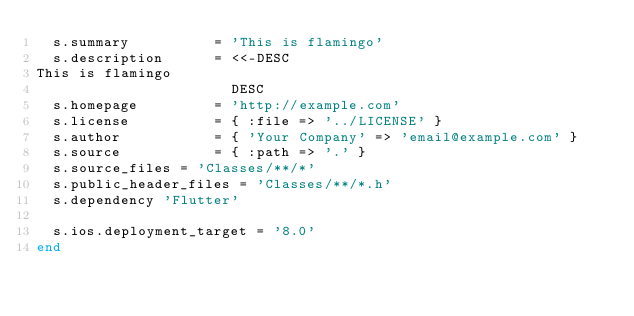Convert code to text. <code><loc_0><loc_0><loc_500><loc_500><_Ruby_>  s.summary          = 'This is flamingo'
  s.description      = <<-DESC
This is flamingo
                       DESC
  s.homepage         = 'http://example.com'
  s.license          = { :file => '../LICENSE' }
  s.author           = { 'Your Company' => 'email@example.com' }
  s.source           = { :path => '.' }
  s.source_files = 'Classes/**/*'
  s.public_header_files = 'Classes/**/*.h'
  s.dependency 'Flutter'

  s.ios.deployment_target = '8.0'
end

</code> 